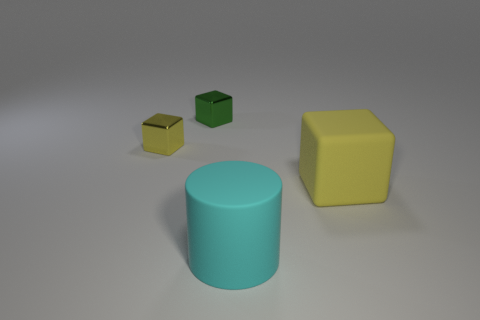The green thing that is the same material as the tiny yellow thing is what shape?
Keep it short and to the point. Cube. Is the number of cyan rubber cylinders that are right of the large cyan cylinder greater than the number of tiny yellow things?
Your answer should be compact. No. What number of big matte blocks have the same color as the large cylinder?
Provide a succinct answer. 0. What number of other things are there of the same color as the big cylinder?
Provide a short and direct response. 0. Is the number of tiny cubes greater than the number of things?
Offer a very short reply. No. What is the big cylinder made of?
Your response must be concise. Rubber. There is a yellow block that is in front of the yellow shiny cube; is it the same size as the big cyan rubber cylinder?
Your response must be concise. Yes. What is the size of the yellow cube on the left side of the cyan object?
Ensure brevity in your answer.  Small. What number of tiny gray metal balls are there?
Offer a terse response. 0. What is the color of the block that is in front of the green object and to the right of the tiny yellow metallic cube?
Provide a short and direct response. Yellow. 